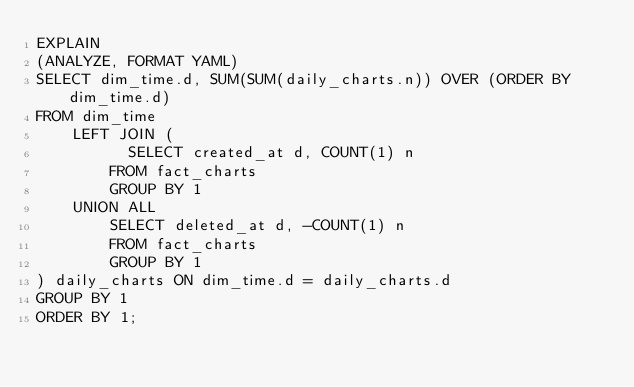Convert code to text. <code><loc_0><loc_0><loc_500><loc_500><_SQL_>EXPLAIN
(ANALYZE, FORMAT YAML)
SELECT dim_time.d, SUM(SUM(daily_charts.n)) OVER (ORDER BY dim_time.d)
FROM dim_time
    LEFT JOIN (
	        SELECT created_at d, COUNT(1) n
        FROM fact_charts
        GROUP BY 1
    UNION ALL
        SELECT deleted_at d, -COUNT(1) n
        FROM fact_charts
        GROUP BY 1
) daily_charts ON dim_time.d = daily_charts.d
GROUP BY 1
ORDER BY 1;
</code> 